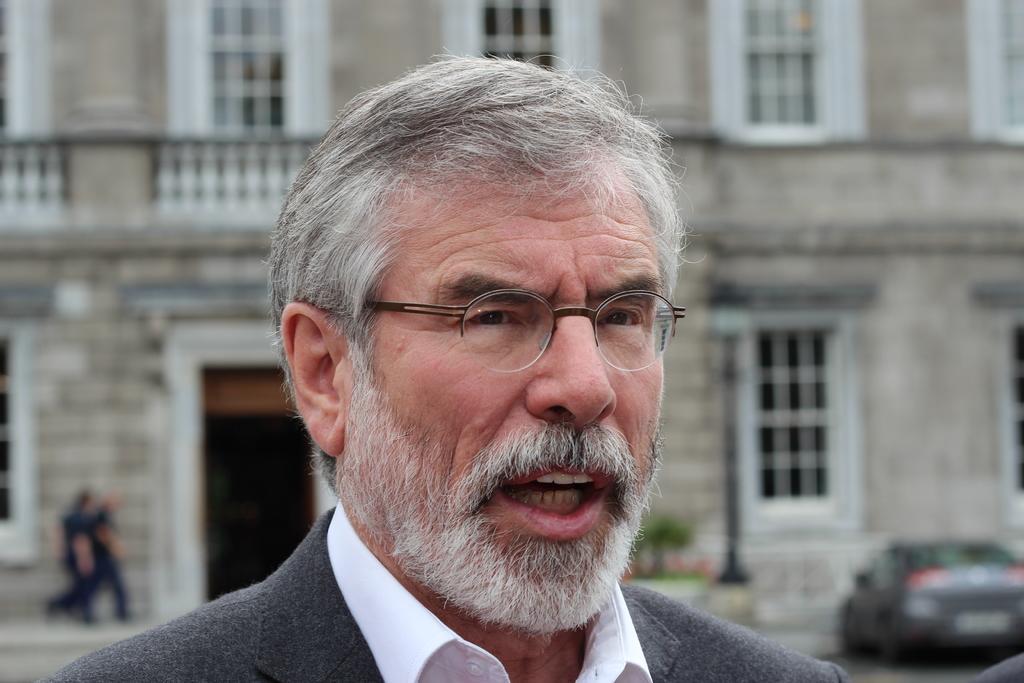Can you describe this image briefly? In this image I can see the person with white and grey color dress. In the background I can see the few more people, vehicle and the building with windows. I can also see the plant. And the background is blurred. 